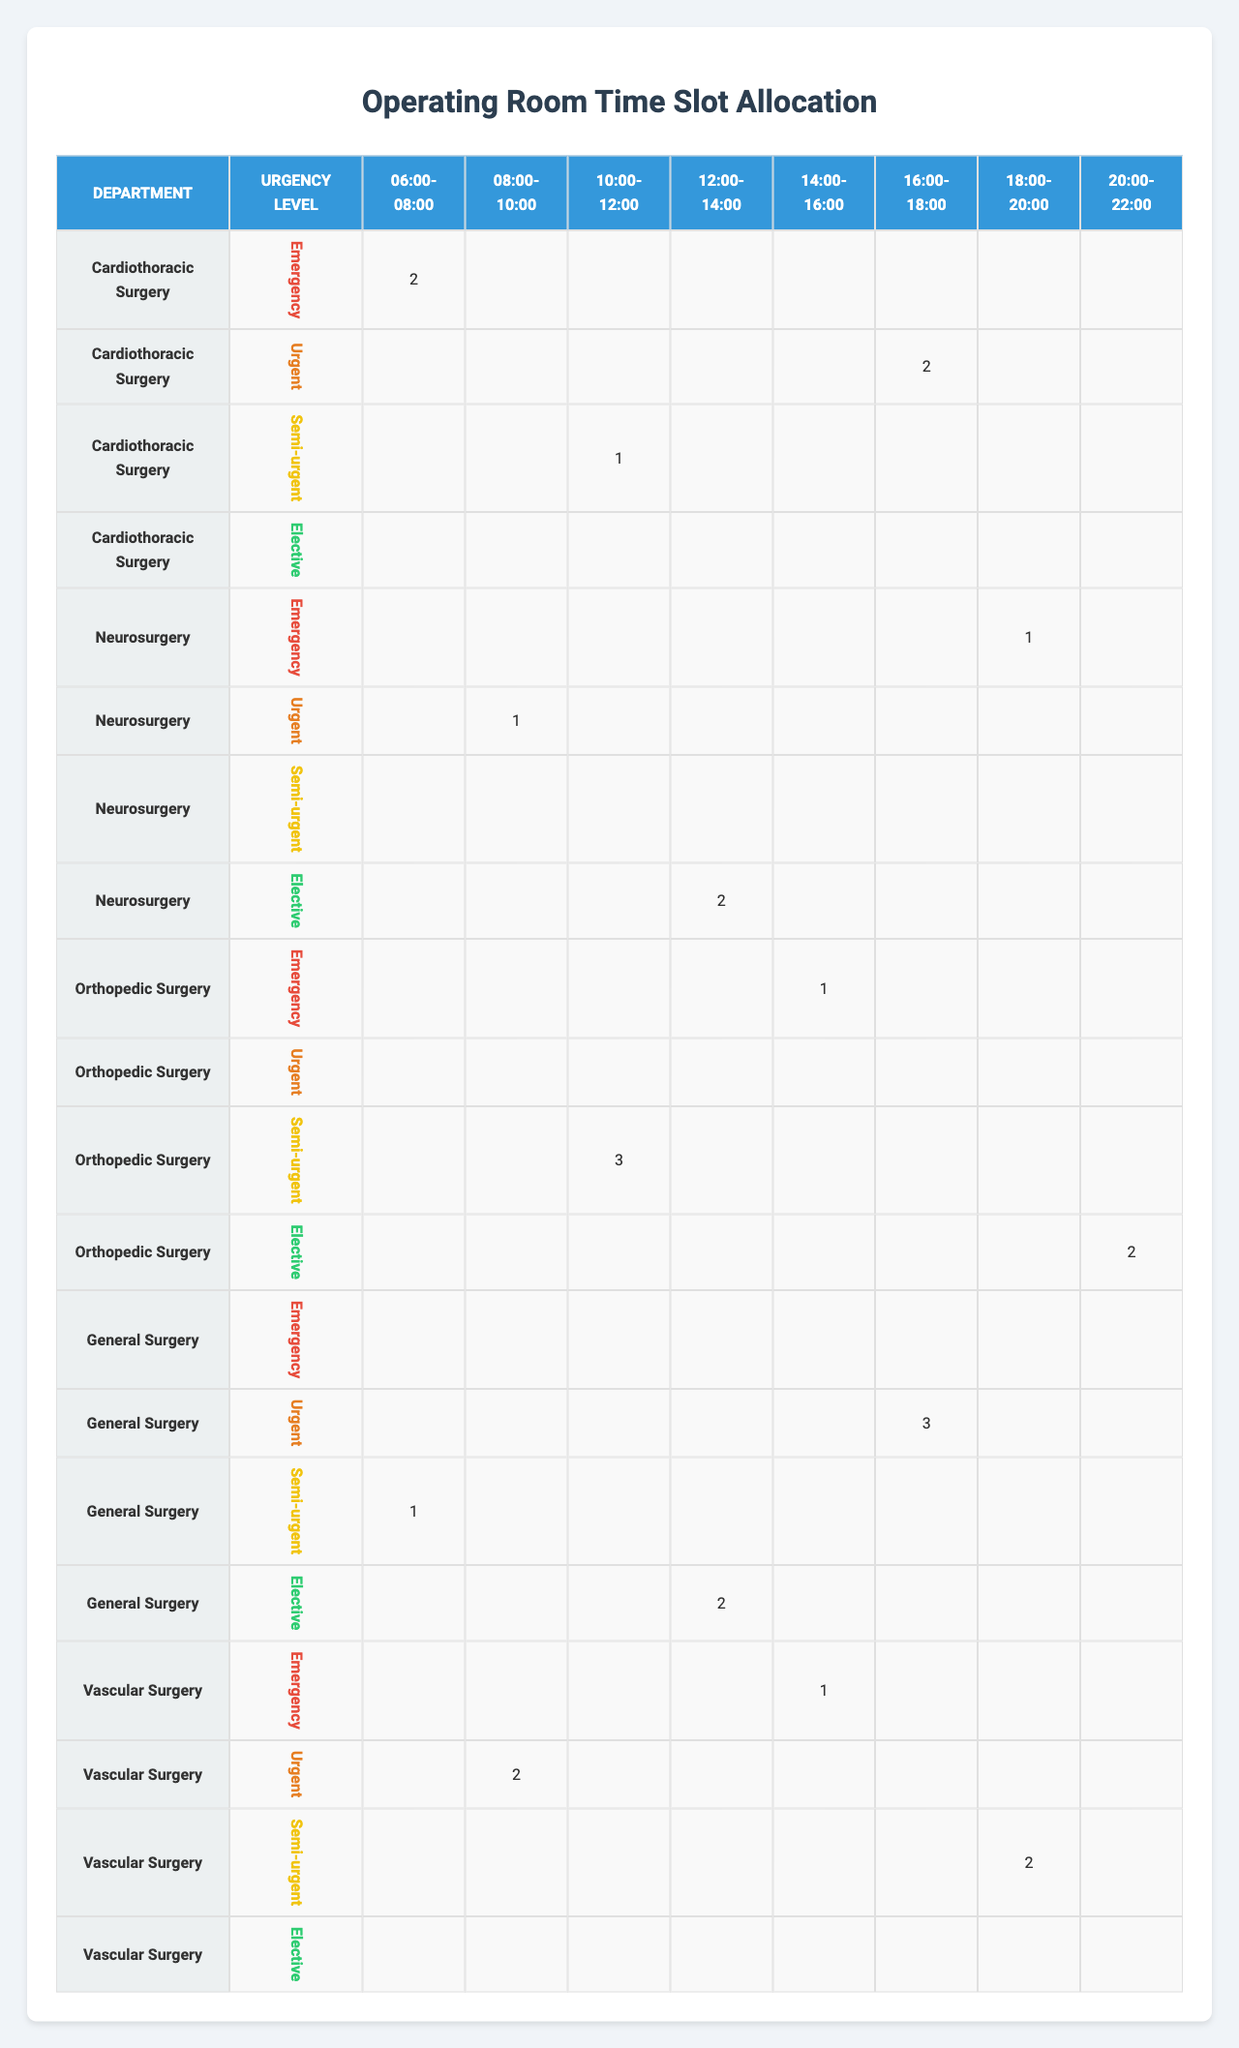What department has the most cases scheduled for Emergency procedures? In the table under the Emergency urgency level, Cardiothoracic Surgery has 2 cases scheduled during the 06:00-08:00 time slot and Neurosurgery has 1 case during 18:00-20:00, while Orthopedic Surgery has 1 case under the 14:00-16:00 time slot. Thus, Cardiothoracic Surgery has the most cases with a total of 2.
Answer: Cardiothoracic Surgery How many total cases are scheduled for Elective surgeries across all departments? Looking at the Elective urgency level, we have 2 cases in Neurosurgery at 12:00-14:00 and 2 cases in Orthopedic Surgery at 20:00-22:00. Adding these gives us a total of 2 + 2 = 4 cases.
Answer: 4 Is there any department with no scheduled cases for Urgent procedures? The table shows that General Surgery has 3 cases currently scheduled for the Urgent urgency level during the 16:00-18:00 time slot. All other departments have at least one case scheduled except for Orthopedic Surgery which has no Urgent cases.
Answer: Yes What is the average number of cases for Semi-urgent procedures across all time slots? For Semi-urgent cases, Cardiothoracic Surgery has 1 case, Orthopedic Surgery has 3 cases, and Vascular Surgery has 2 cases. The sum is 1 + 3 + 2 = 6, and since there are 3 departments, the average is 6 / 3 = 2.
Answer: 2 Which time slot has the least number of cases scheduled in total? By adding cases across all departments for each time slot: 06:00-08:00 has (2 + 1 + 1 + 0 + 0) = 4; 08:00-10:00 has (0 + 1 + 0 + 0 + 2) = 3; 10:00-12:00 has (1 + 0 + 3 + 0 + 0) = 4; 12:00-14:00 has (0 + 2 + 0 + 2 + 0) = 4; 14:00-16:00 has (1 + 0 + 1 + 0 + 1) = 3; 16:00-18:00 has (2 + 3 + 0 + 0 + 0) = 5; 18:00-20:00 has (0 + 0 + 0 + 0 + 2) = 2; and finally 20:00-22:00 has (0 + 0 + 2 + 0 + 0) = 2. The least cases occur at both 18:00-20:00 and 20:00-22:00 with 2 cases each.
Answer: 18:00-20:00 and 20:00-22:00 How many more Urgent cases are scheduled in General Surgery compared to Vascular Surgery? General Surgery has 3 Urgent cases during the 16:00-18:00 time slot while Vascular Surgery has 2 Urgent cases scheduled during the 08:00-10:00 time slot. Therefore, the difference is 3 - 2 = 1 case more in General Surgery.
Answer: 1 Which department performs Emergency surgeries at the latest time slot? In the table, Neurosurgery has 1 case for Emergency surgeries scheduled in the 18:00-20:00 time slot, which is the latest time slot for Emergency procedures when compared to Cardiothoracic and Vascular surgeries which are scheduled earlier.
Answer: Neurosurgery 